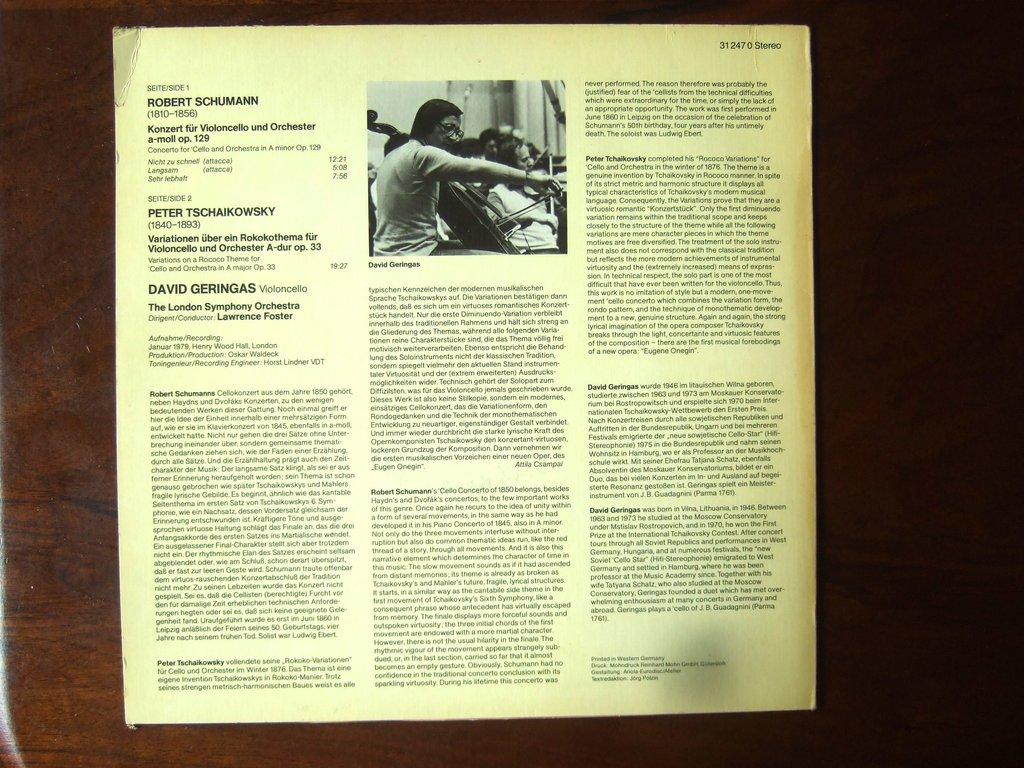What is written on the paper that is visible in the image? The paper in the image has paragraphs on it. What else can be seen in the image besides the paper? There is a photo in the image. How are the paper and photo displayed in the image? Both the paper and photo are attached to a wooden board. How many snails can be seen crawling on the wooden board in the image? There are no snails visible in the image. Is there a cobweb in the corner of the wooden board in the image? There is no cobweb visible in the image. 